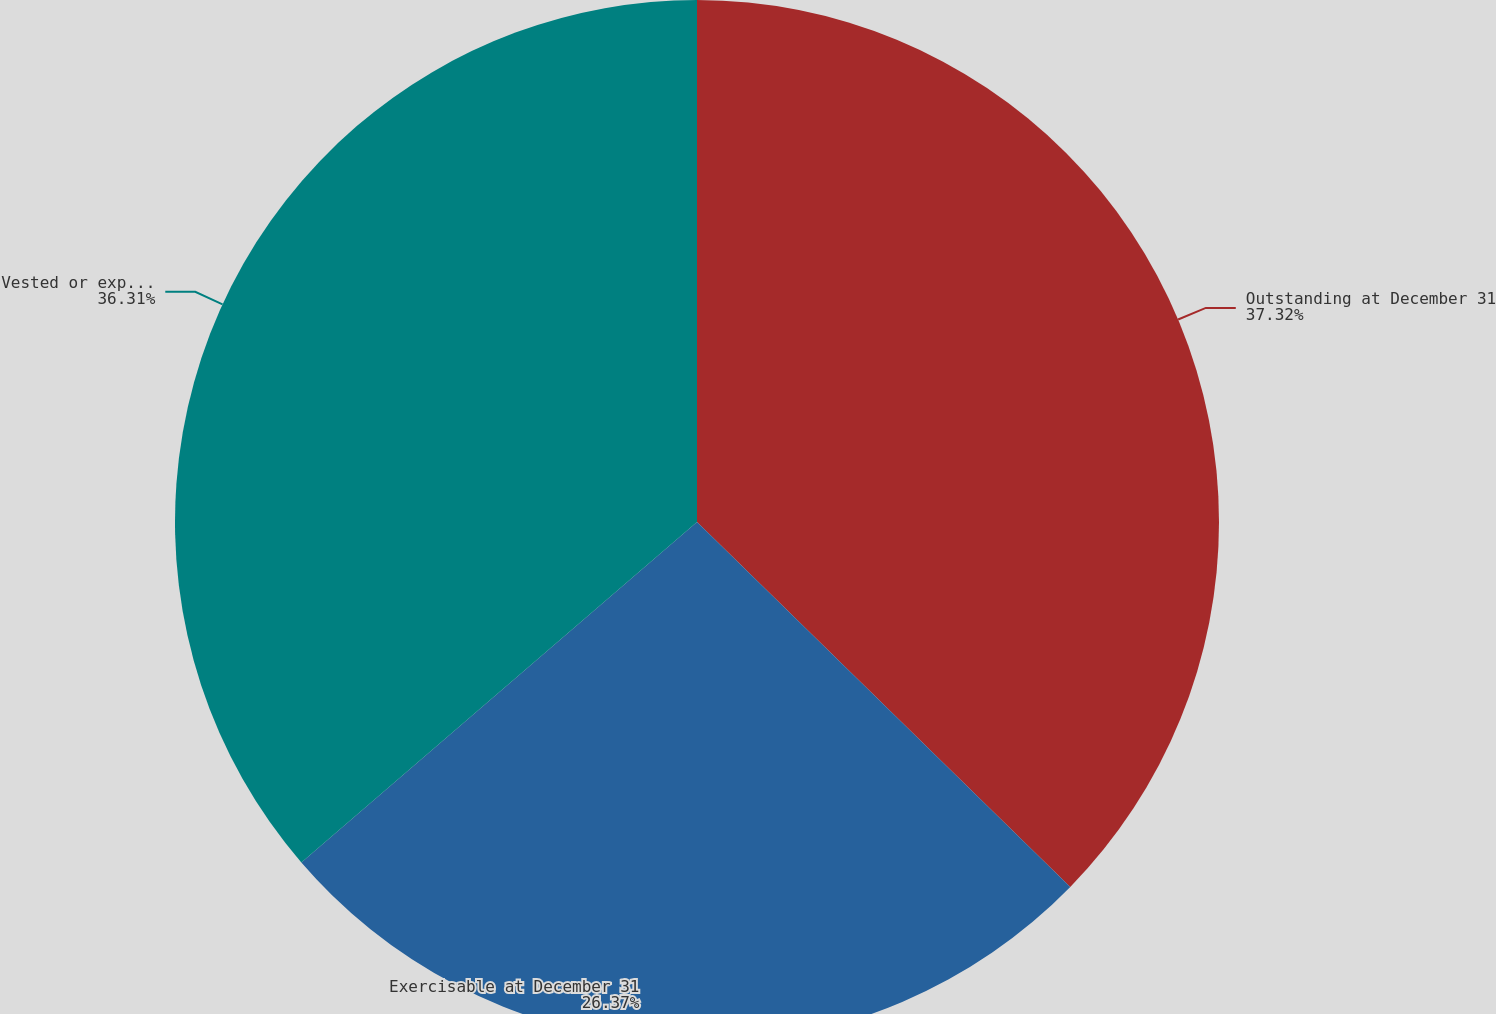<chart> <loc_0><loc_0><loc_500><loc_500><pie_chart><fcel>Outstanding at December 31<fcel>Exercisable at December 31<fcel>Vested or expected to vest<nl><fcel>37.32%<fcel>26.37%<fcel>36.31%<nl></chart> 